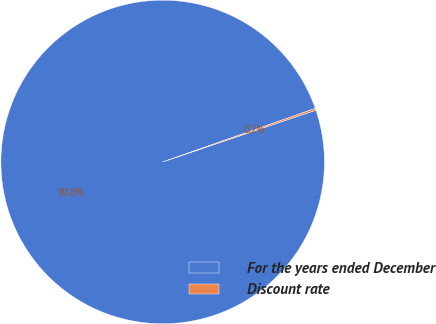<chart> <loc_0><loc_0><loc_500><loc_500><pie_chart><fcel>For the years ended December<fcel>Discount rate<nl><fcel>99.81%<fcel>0.19%<nl></chart> 